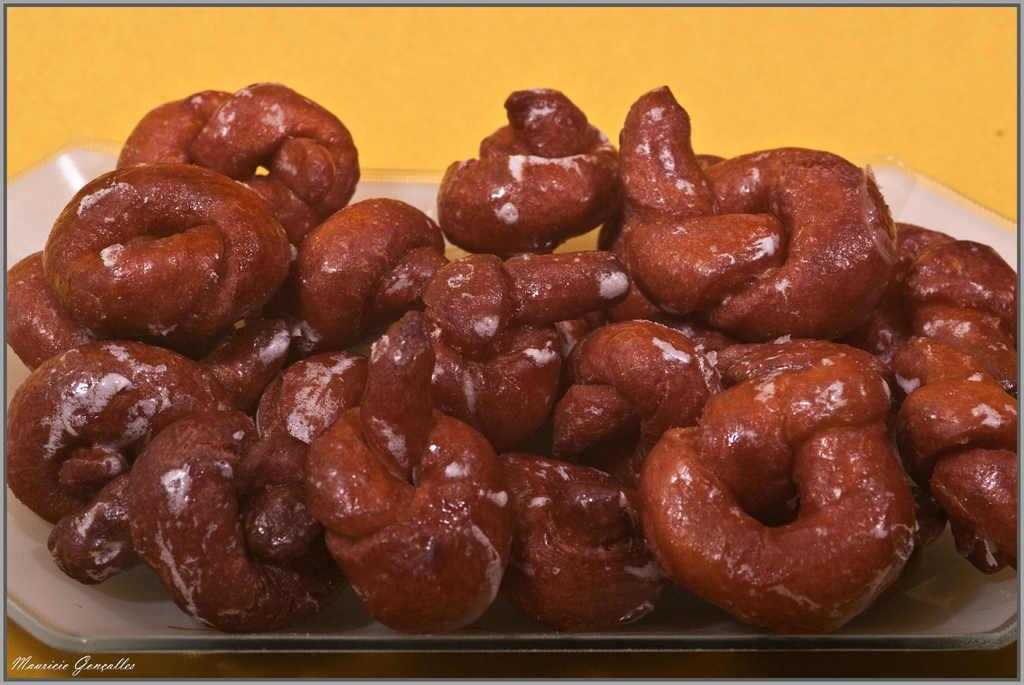What is on the tray that is visible in the image? There are pretzels on the tray in the image. What is the color of the tray? The tray is white. What is the color of the surface on which the tray is placed? The surface is yellow. Can you tell me how many people are in jail in the image? There is no reference to a jail or any people in the image; it features a white tray with pretzels on a yellow surface. What type of touchscreen device is visible in the image? There is no touchscreen device present in the image. 